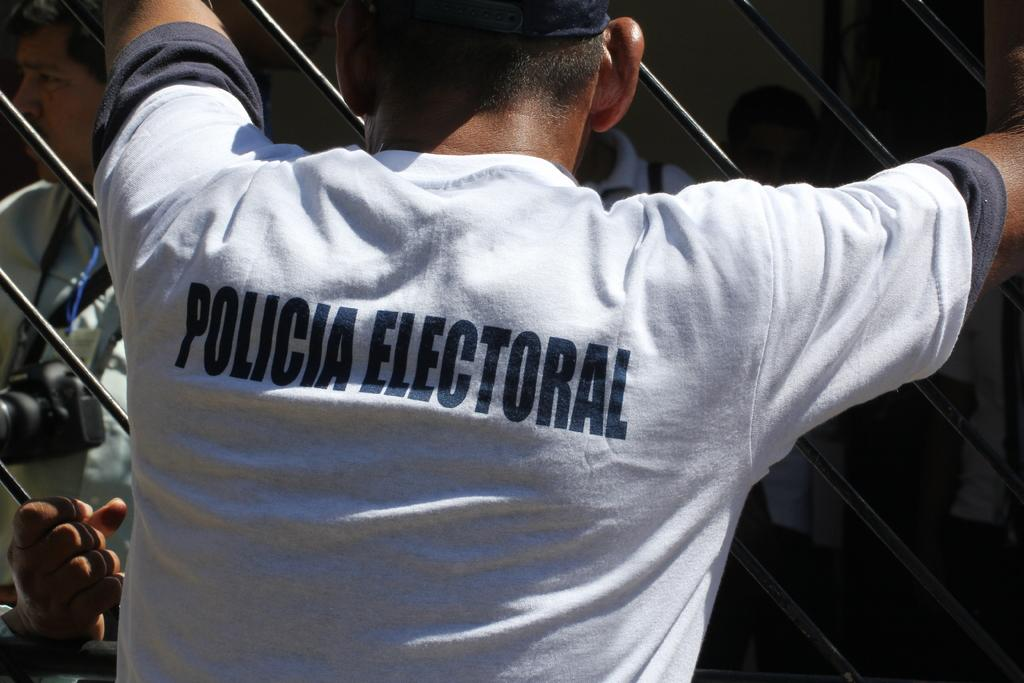<image>
Provide a brief description of the given image. A man is wearing a shirt with the words policia electoral on the back. 